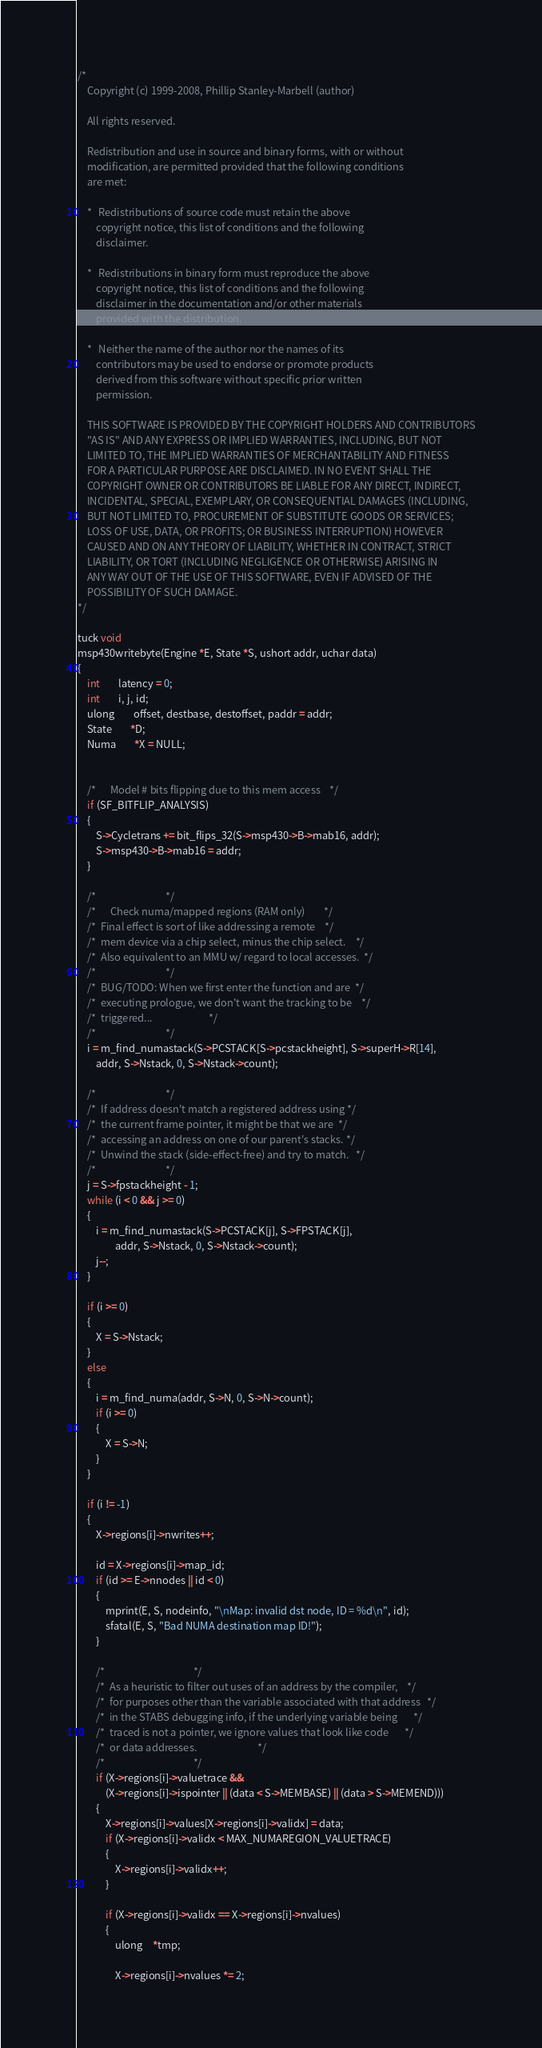Convert code to text. <code><loc_0><loc_0><loc_500><loc_500><_C_>/*
	Copyright (c) 1999-2008, Phillip Stanley-Marbell (author)
 
	All rights reserved.

	Redistribution and use in source and binary forms, with or without 
	modification, are permitted provided that the following conditions
	are met:

	*	Redistributions of source code must retain the above
		copyright notice, this list of conditions and the following
		disclaimer.

	*	Redistributions in binary form must reproduce the above
		copyright notice, this list of conditions and the following
		disclaimer in the documentation and/or other materials
		provided with the distribution.

	*	Neither the name of the author nor the names of its
		contributors may be used to endorse or promote products
		derived from this software without specific prior written 
		permission.

	THIS SOFTWARE IS PROVIDED BY THE COPYRIGHT HOLDERS AND CONTRIBUTORS
	"AS IS" AND ANY EXPRESS OR IMPLIED WARRANTIES, INCLUDING, BUT NOT
	LIMITED TO, THE IMPLIED WARRANTIES OF MERCHANTABILITY AND FITNESS
	FOR A PARTICULAR PURPOSE ARE DISCLAIMED. IN NO EVENT SHALL THE 
	COPYRIGHT OWNER OR CONTRIBUTORS BE LIABLE FOR ANY DIRECT, INDIRECT,
	INCIDENTAL, SPECIAL, EXEMPLARY, OR CONSEQUENTIAL DAMAGES (INCLUDING,
	BUT NOT LIMITED TO, PROCUREMENT OF SUBSTITUTE GOODS OR SERVICES; 
	LOSS OF USE, DATA, OR PROFITS; OR BUSINESS INTERRUPTION) HOWEVER 
	CAUSED AND ON ANY THEORY OF LIABILITY, WHETHER IN CONTRACT, STRICT
	LIABILITY, OR TORT (INCLUDING NEGLIGENCE OR OTHERWISE) ARISING IN 
	ANY WAY OUT OF THE USE OF THIS SOFTWARE, EVEN IF ADVISED OF THE 
	POSSIBILITY OF SUCH DAMAGE.
*/

tuck void
msp430writebyte(Engine *E, State *S, ushort addr, uchar data)
{
	int		latency = 0;
	int		i, j, id;
	ulong		offset, destbase, destoffset, paddr = addr;
	State		*D;
	Numa		*X = NULL;


	/*		Model # bits flipping due to this mem access	*/
	if (SF_BITFLIP_ANALYSIS)
	{
		S->Cycletrans += bit_flips_32(S->msp430->B->mab16, addr);
		S->msp430->B->mab16 = addr;
	}

	/*								*/
	/*	   	Check numa/mapped regions (RAM only)		*/
	/*	Final effect is sort of like addressing a remote 	*/
	/*	mem device via a chip select, minus the chip select.	*/
	/*	Also equivalent to an MMU w/ regard to local accesses.	*/
	/*								*/
	/*	BUG/TODO: When we first enter the function and are 	*/
	/*	executing prologue, we don't want the tracking to be 	*/
	/*	triggered...						*/
	/*								*/
	i = m_find_numastack(S->PCSTACK[S->pcstackheight], S->superH->R[14],
		addr, S->Nstack, 0, S->Nstack->count);

	/*								*/
	/*	If address doesn't match a registered address using	*/
	/*	the current frame pointer, it might be that we are	*/
	/*	accessing an address on one of our parent's stacks.	*/
	/*	Unwind the stack (side-effect-free) and try to match.	*/
	/*								*/
	j = S->fpstackheight - 1;
	while (i < 0 && j >= 0)
	{
		i = m_find_numastack(S->PCSTACK[j], S->FPSTACK[j],
				addr, S->Nstack, 0, S->Nstack->count);
		j--;
	}

	if (i >= 0)
	{
		X = S->Nstack;
	}
	else
	{
		i = m_find_numa(addr, S->N, 0, S->N->count);
		if (i >= 0)
		{
			X = S->N;
		}
	}

	if (i != -1)
	{
		X->regions[i]->nwrites++;

		id = X->regions[i]->map_id;
		if (id >= E->nnodes || id < 0) 
		{
			mprint(E, S, nodeinfo, "\nMap: invalid dst node, ID = %d\n", id);
			sfatal(E, S, "Bad NUMA destination map ID!");
		}

		/*										*/
		/*	As a heuristic to filter out uses of an address by the compiler,	*/
		/*	for purposes other than the variable associated with that address	*/
		/*	in the STABS debugging info, if the underlying variable being		*/
		/*	traced is not a pointer, we ignore values that look like code		*/
		/*	or data addresses.							*/
		/*										*/
		if (X->regions[i]->valuetrace &&
			(X->regions[i]->ispointer || (data < S->MEMBASE) || (data > S->MEMEND)))
		{
			X->regions[i]->values[X->regions[i]->validx] = data;
			if (X->regions[i]->validx < MAX_NUMAREGION_VALUETRACE)
			{
				X->regions[i]->validx++;
			}

			if (X->regions[i]->validx == X->regions[i]->nvalues)
			{
				ulong	*tmp;

				X->regions[i]->nvalues *= 2;</code> 